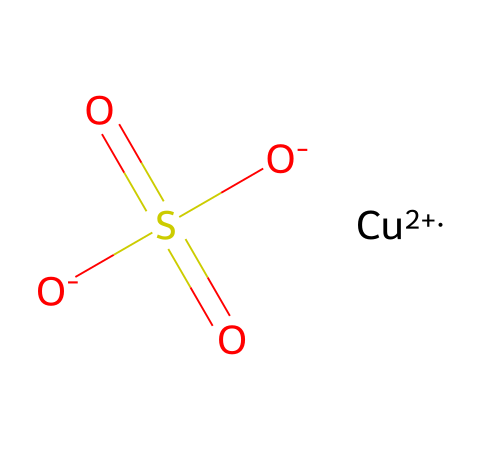What is the name of this chemical? The SMILES notation indicates that this compound contains copper (Cu), sulfur (S), and oxygen (O), which corresponds to the name copper sulfate.
Answer: copper sulfate How many oxygen atoms are present in this structure? By examining the SMILES representation, we can count the number of oxygen atoms: there are four oxygen atoms bonded in the molecular structure.
Answer: four What is the oxidation state of copper in this compound? In this chemical structure, copper is denoted as Cu+2, indicating that it has a +2 oxidation state.
Answer: +2 What type of compound is copper sulfate classified as? Copper sulfate is categorized as a salt because it is formed from the neutralization reaction between an acid (sulfuric acid) and a base (copper hydroxide).
Answer: salt How many total atoms are in copper sulfate? The components of copper sulfate consist of one copper atom, one sulfur atom, and four oxygen atoms, resulting in a total of six atoms in the molecular structure.
Answer: six What does the "S(=O)(=O)" part signify in the structure? The notation "S(=O)(=O)" indicates that the sulfur atom is bonded to two double-bonded oxygen atoms, which suggests that the sulfur is in a sulfate form, characteristic of sulfate ions.
Answer: sulfate What role does copper sulfate play in algaecides? Copper sulfate acts as an algaecide, which means it helps in the control and removal of algae in water bodies by disrupting their cellular functions.
Answer: algaecide 